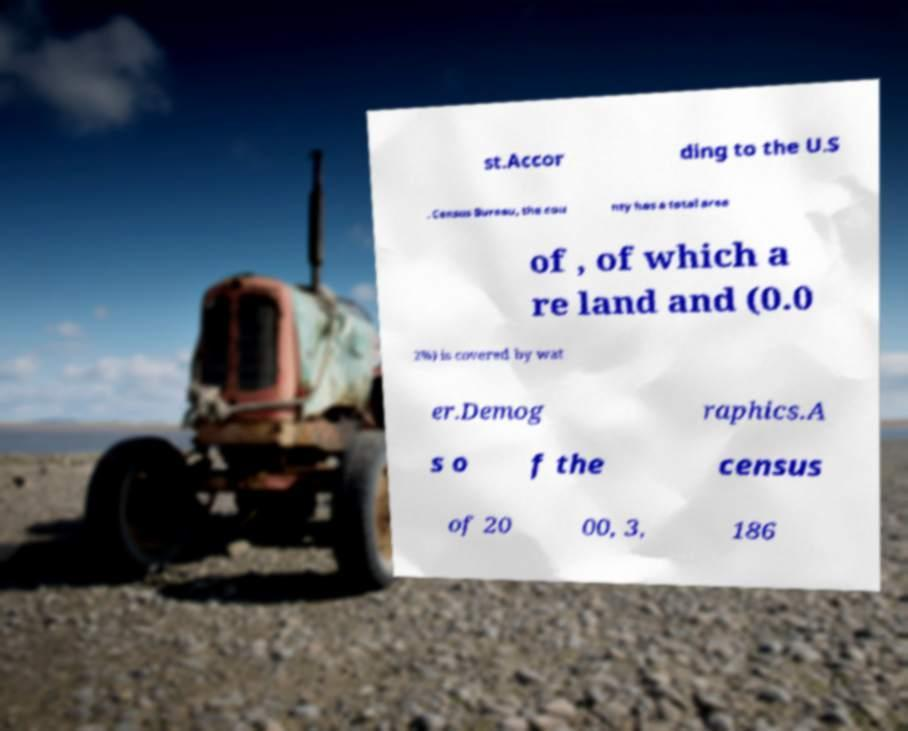Can you read and provide the text displayed in the image?This photo seems to have some interesting text. Can you extract and type it out for me? st.Accor ding to the U.S . Census Bureau, the cou nty has a total area of , of which a re land and (0.0 2%) is covered by wat er.Demog raphics.A s o f the census of 20 00, 3, 186 